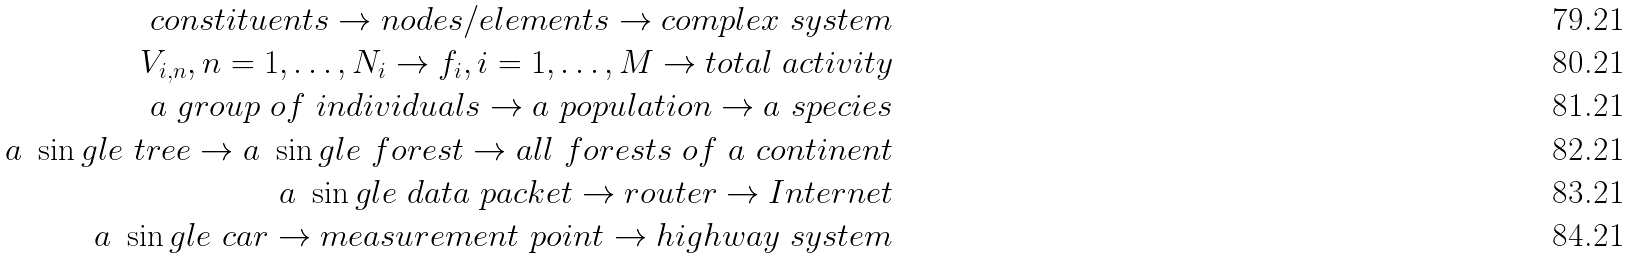Convert formula to latex. <formula><loc_0><loc_0><loc_500><loc_500>c o n s t i t u e n t s \rightarrow n o d e s / e l e m e n t s \rightarrow c o m p l e x \ s y s t e m \\ V _ { i , n } , n = 1 , \dots , N _ { i } \rightarrow f _ { i } , i = 1 , \dots , M \rightarrow t o t a l \ a c t i v i t y \\ a \ g r o u p \ o f \ i n d i v i d u a l s \rightarrow a \ p o p u l a t i o n \rightarrow a \ s p e c i e s \\ a \ \sin g l e \ t r e e \rightarrow a \ \sin g l e \ f o r e s t \rightarrow a l l \ f o r e s t s \ o f \ a \ c o n t i n e n t \\ a \ \sin g l e \ d a t a \ p a c k e t \rightarrow r o u t e r \rightarrow I n t e r n e t \\ a \ \sin g l e \ c a r \rightarrow m e a s u r e m e n t \ p o i n t \rightarrow h i g h w a y \ s y s t e m</formula> 